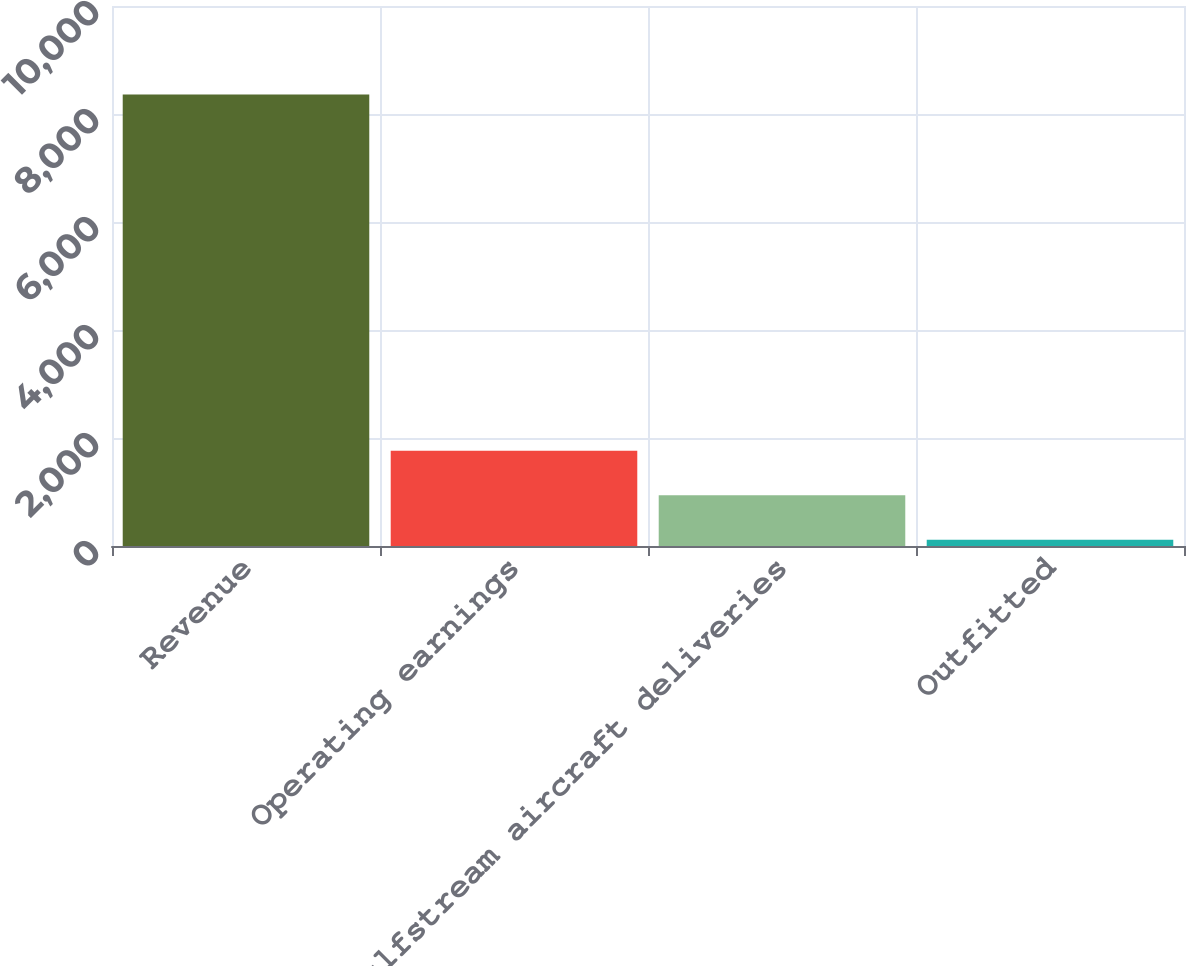Convert chart. <chart><loc_0><loc_0><loc_500><loc_500><bar_chart><fcel>Revenue<fcel>Operating earnings<fcel>Gulfstream aircraft deliveries<fcel>Outfitted<nl><fcel>8362<fcel>1764.4<fcel>939.7<fcel>115<nl></chart> 